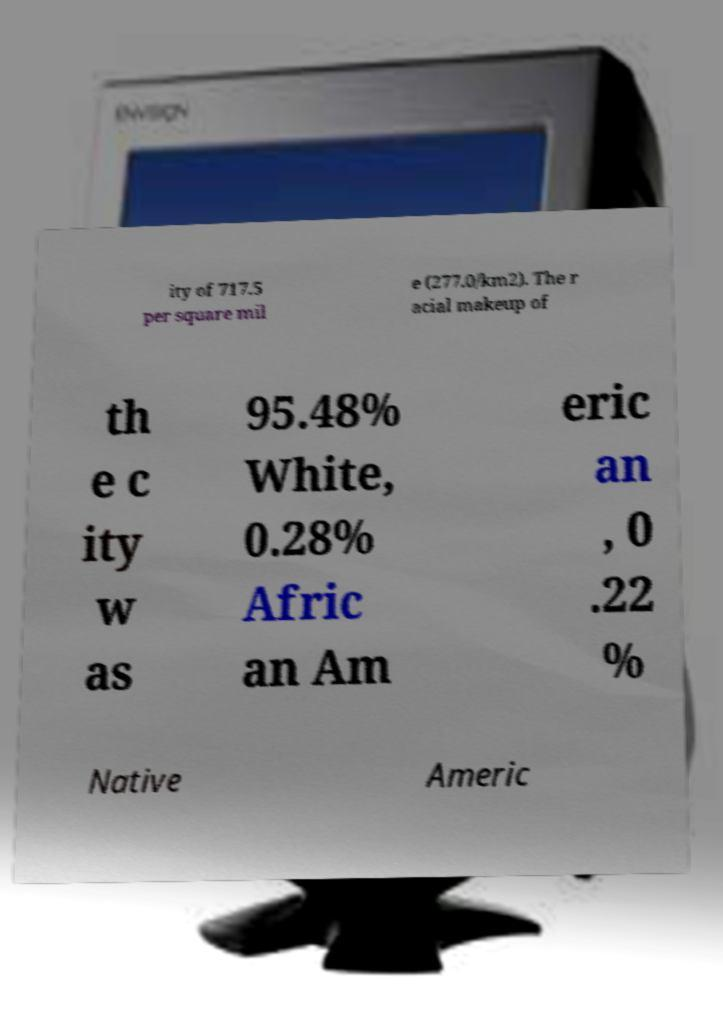I need the written content from this picture converted into text. Can you do that? ity of 717.5 per square mil e (277.0/km2). The r acial makeup of th e c ity w as 95.48% White, 0.28% Afric an Am eric an , 0 .22 % Native Americ 